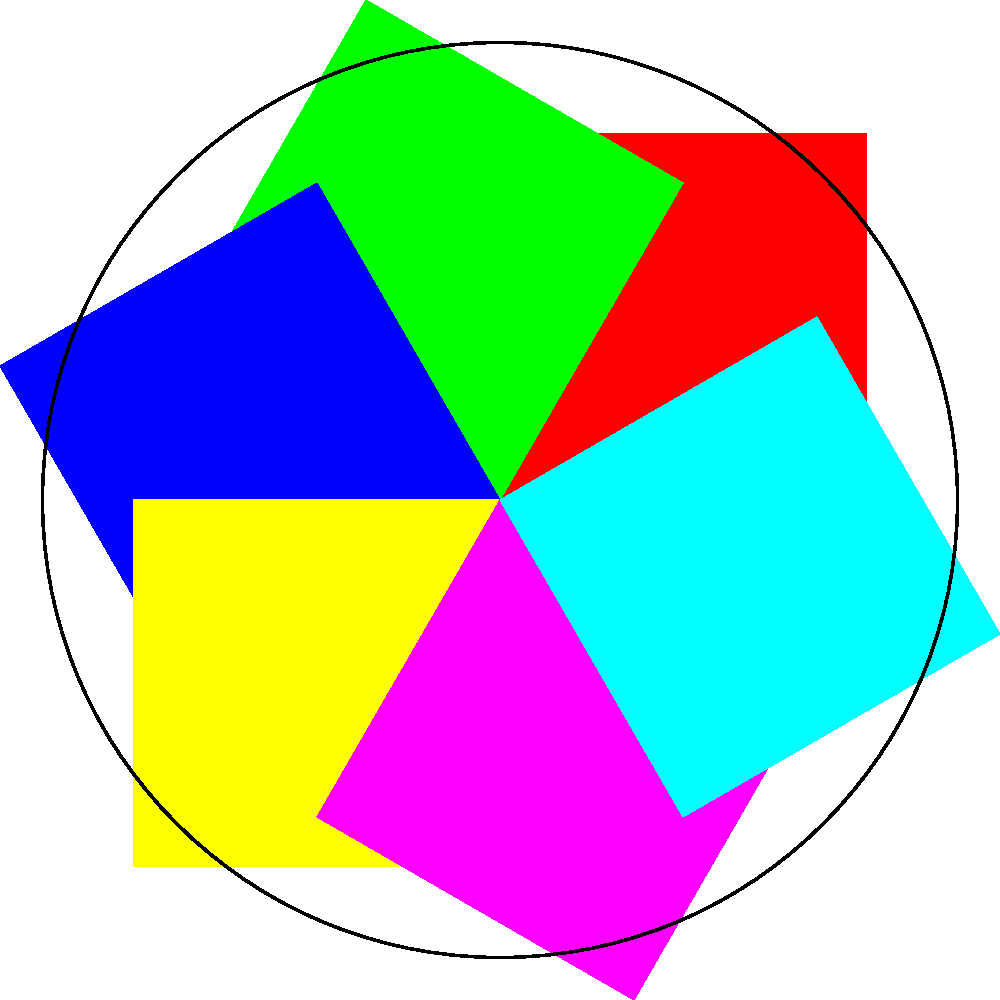In the geometric pattern shown, which color is complementary to the red segment according to traditional color theory? To determine the complementary color of red in this geometric pattern, we need to follow these steps:

1. Identify the color wheel arrangement:
   The pattern shows six colors arranged in a circular format, resembling a simplified color wheel.

2. Recognize the primary and secondary colors:
   - Primary colors: Red, Blue, Yellow
   - Secondary colors: Green, Purple, Cyan

3. Recall the principle of complementary colors:
   Complementary colors are directly opposite each other on the color wheel.

4. Locate the red segment:
   The red segment is at the top of the circle.

5. Find the color directly opposite red:
   Moving 180 degrees around the circle from red, we find green.

6. Confirm the complementary relationship:
   In traditional color theory, red and green are indeed complementary colors.

Therefore, the color complementary to the red segment in this geometric pattern is green.
Answer: Green 